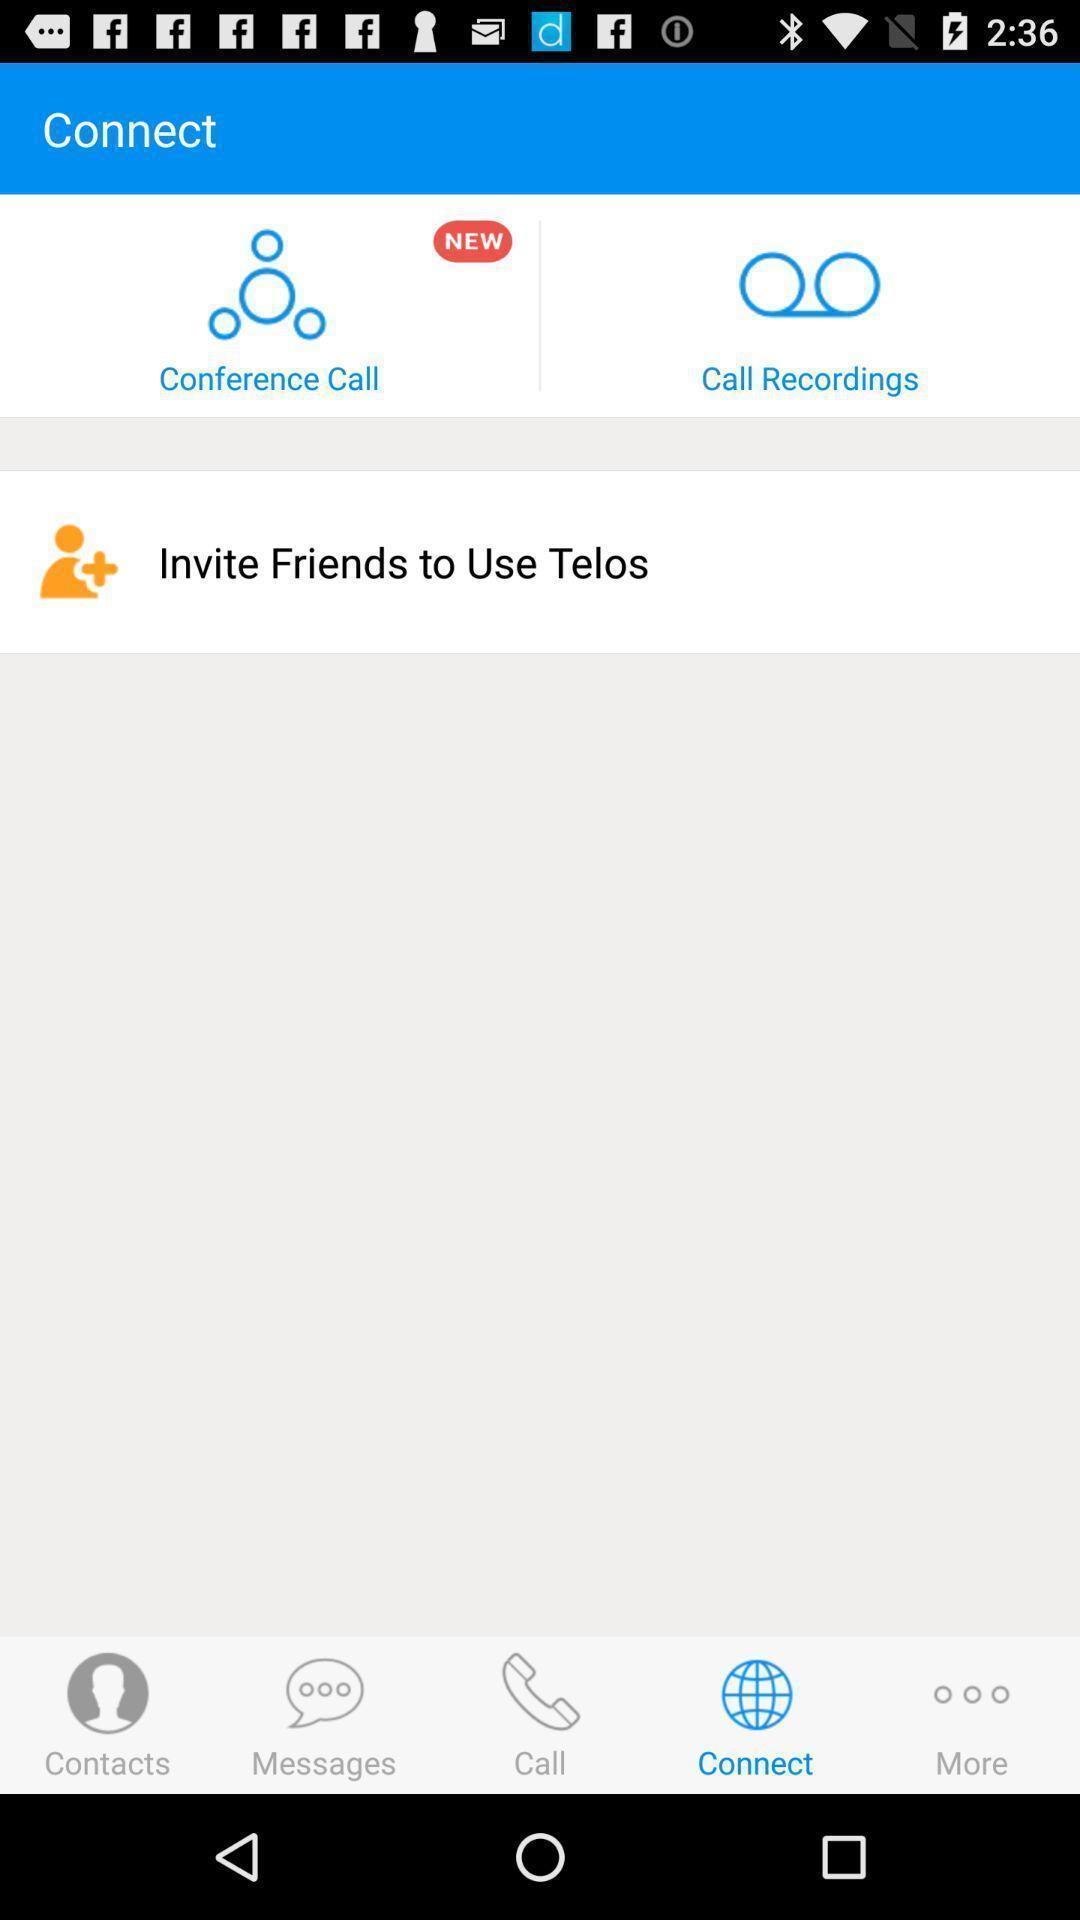Describe the content in this image. Page showing information of call. 